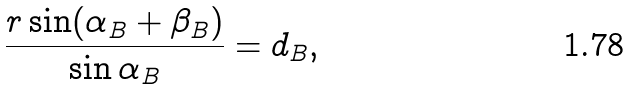Convert formula to latex. <formula><loc_0><loc_0><loc_500><loc_500>\frac { r \sin ( \alpha _ { B } + \beta _ { B } ) } { \sin \alpha _ { B } } = d _ { B } ,</formula> 